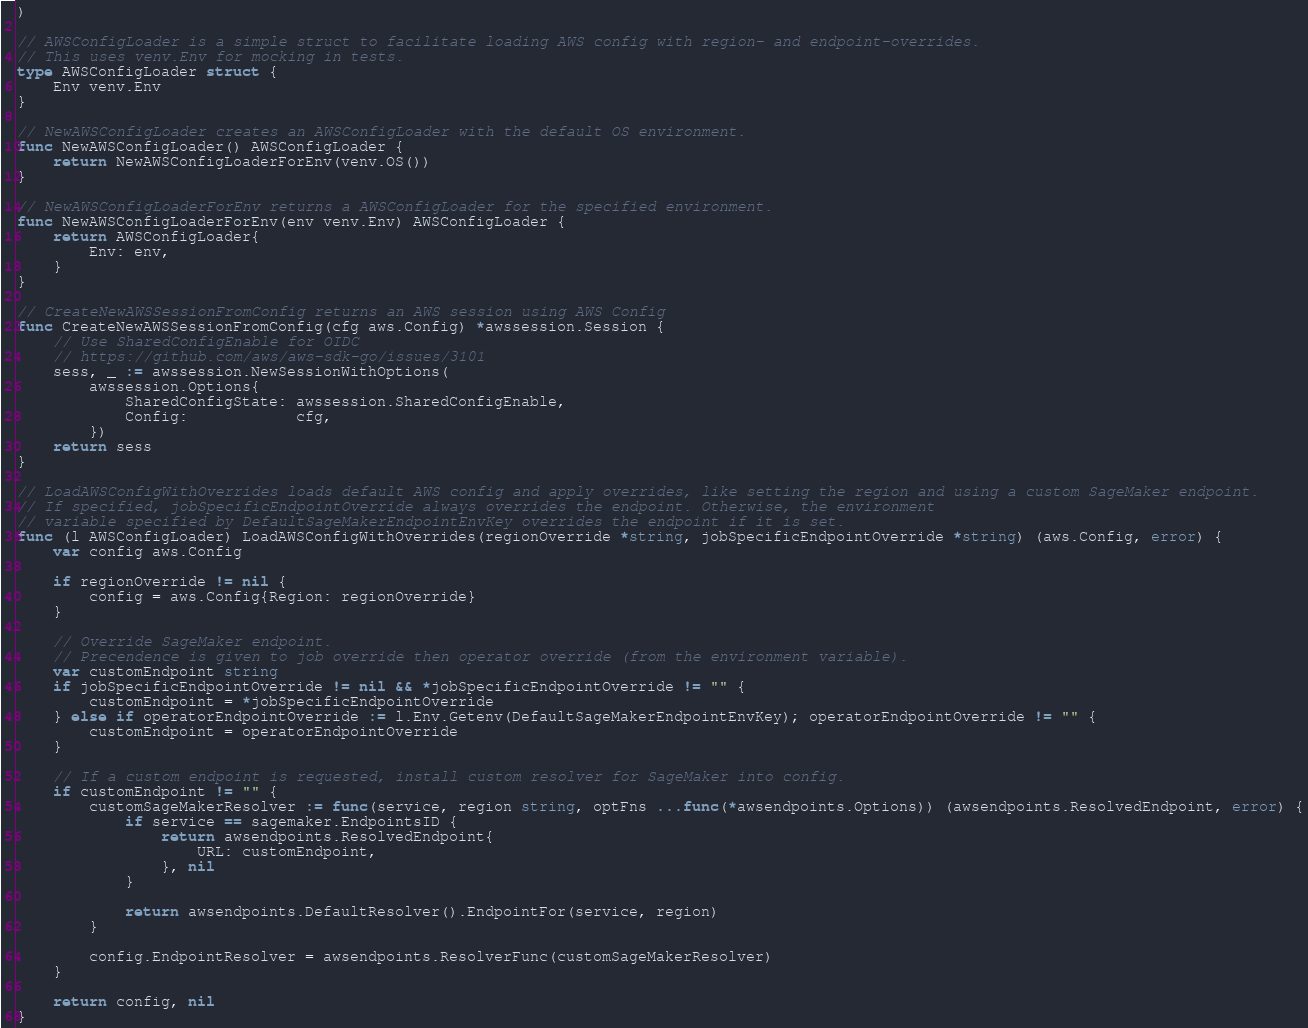<code> <loc_0><loc_0><loc_500><loc_500><_Go_>)

// AWSConfigLoader is a simple struct to facilitate loading AWS config with region- and endpoint-overrides.
// This uses venv.Env for mocking in tests.
type AWSConfigLoader struct {
	Env venv.Env
}

// NewAWSConfigLoader creates an AWSConfigLoader with the default OS environment.
func NewAWSConfigLoader() AWSConfigLoader {
	return NewAWSConfigLoaderForEnv(venv.OS())
}

// NewAWSConfigLoaderForEnv returns a AWSConfigLoader for the specified environment.
func NewAWSConfigLoaderForEnv(env venv.Env) AWSConfigLoader {
	return AWSConfigLoader{
		Env: env,
	}
}

// CreateNewAWSSessionFromConfig returns an AWS session using AWS Config
func CreateNewAWSSessionFromConfig(cfg aws.Config) *awssession.Session {
	// Use SharedConfigEnable for OIDC
	// https://github.com/aws/aws-sdk-go/issues/3101
	sess, _ := awssession.NewSessionWithOptions(
		awssession.Options{
			SharedConfigState: awssession.SharedConfigEnable,
			Config:            cfg,
		})
	return sess
}

// LoadAWSConfigWithOverrides loads default AWS config and apply overrides, like setting the region and using a custom SageMaker endpoint.
// If specified, jobSpecificEndpointOverride always overrides the endpoint. Otherwise, the environment
// variable specified by DefaultSageMakerEndpointEnvKey overrides the endpoint if it is set.
func (l AWSConfigLoader) LoadAWSConfigWithOverrides(regionOverride *string, jobSpecificEndpointOverride *string) (aws.Config, error) {
	var config aws.Config

	if regionOverride != nil {
		config = aws.Config{Region: regionOverride}
	}

	// Override SageMaker endpoint.
	// Precendence is given to job override then operator override (from the environment variable).
	var customEndpoint string
	if jobSpecificEndpointOverride != nil && *jobSpecificEndpointOverride != "" {
		customEndpoint = *jobSpecificEndpointOverride
	} else if operatorEndpointOverride := l.Env.Getenv(DefaultSageMakerEndpointEnvKey); operatorEndpointOverride != "" {
		customEndpoint = operatorEndpointOverride
	}

	// If a custom endpoint is requested, install custom resolver for SageMaker into config.
	if customEndpoint != "" {
		customSageMakerResolver := func(service, region string, optFns ...func(*awsendpoints.Options)) (awsendpoints.ResolvedEndpoint, error) {
			if service == sagemaker.EndpointsID {
				return awsendpoints.ResolvedEndpoint{
					URL: customEndpoint,
				}, nil
			}

			return awsendpoints.DefaultResolver().EndpointFor(service, region)
		}

		config.EndpointResolver = awsendpoints.ResolverFunc(customSageMakerResolver)
	}

	return config, nil
}
</code> 